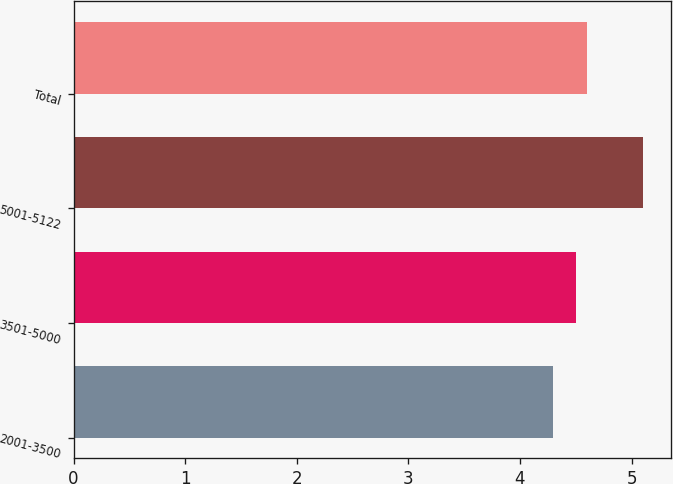<chart> <loc_0><loc_0><loc_500><loc_500><bar_chart><fcel>2001-3500<fcel>3501-5000<fcel>5001-5122<fcel>Total<nl><fcel>4.3<fcel>4.5<fcel>5.1<fcel>4.6<nl></chart> 